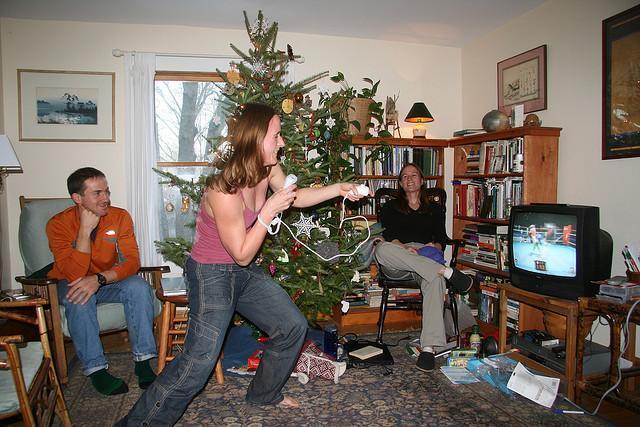How many people can you see?
Give a very brief answer. 3. How many chairs can be seen?
Give a very brief answer. 3. 